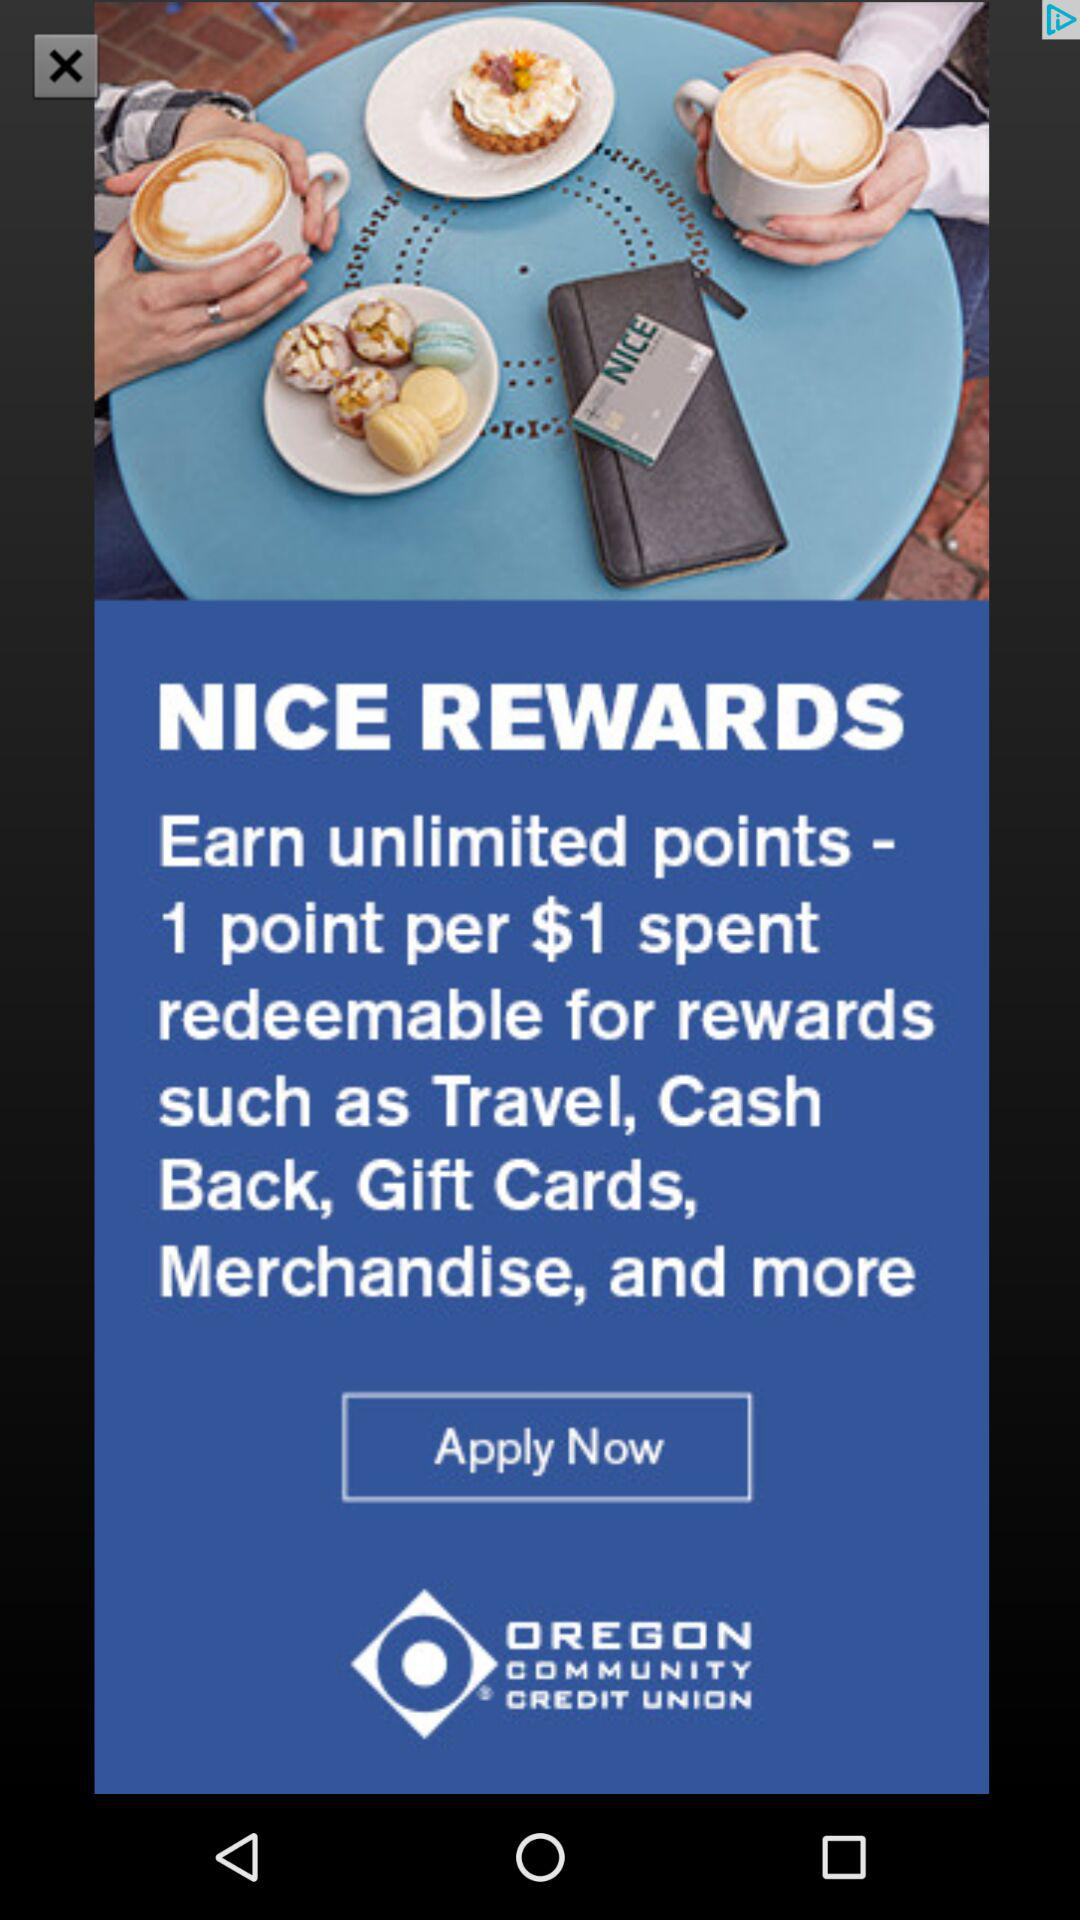How many points are earned per dollar spent?
Answer the question using a single word or phrase. 1 